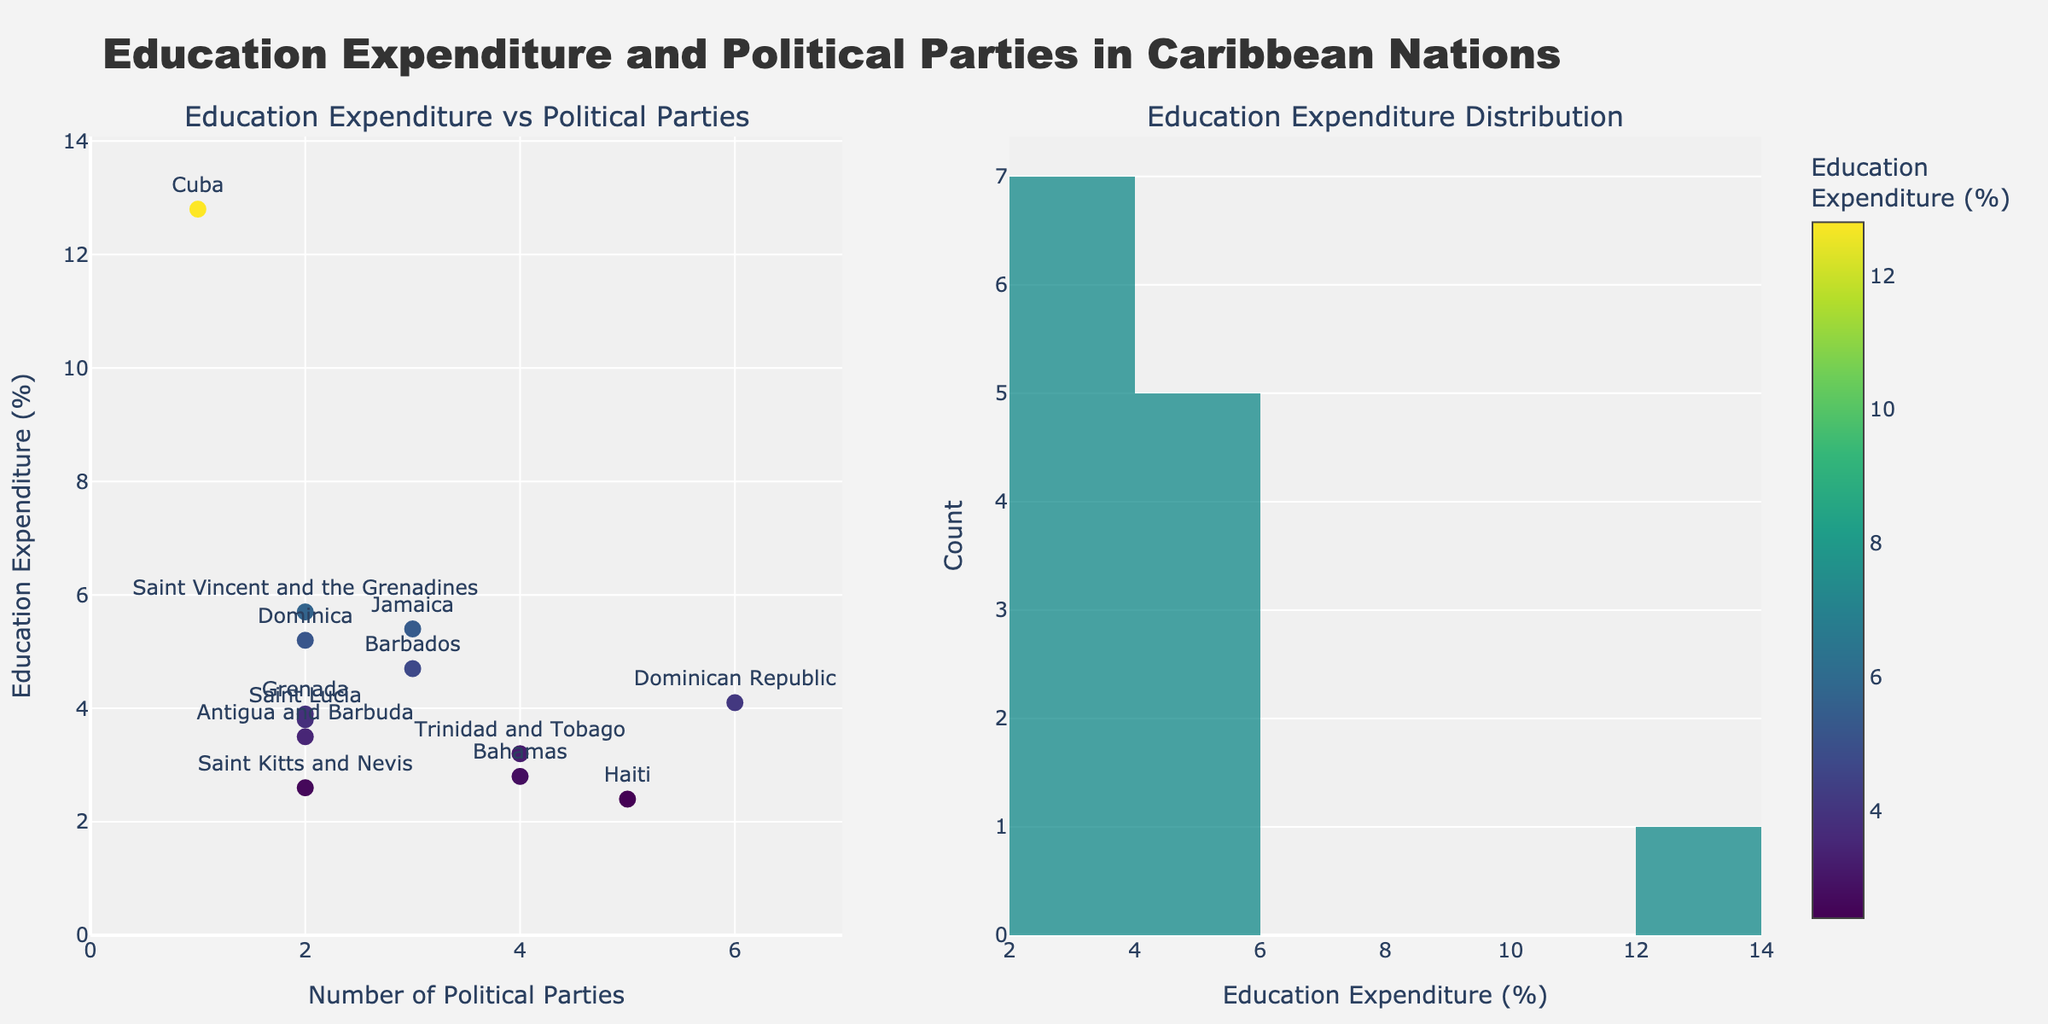What's the title of the subplot figure? The title is generally displayed at the top of the subplot figure. To find the title, you should read the largest text prominently positioned centrally.
Answer: "Education Expenditure and Political Parties in Caribbean Nations" How many Caribbean nations are represented in the scatter plot? To find the number of nations, count the different data points in the scatter plot; each point represents a different country.
Answer: 13 Which country has the highest education expenditure percentage? Look for the highest point in the scatter plot on the y-axis (Education Expenditure Percentage) and identify the country labeled closest to that point.
Answer: Cuba What is the range of the number of political parties in the Caribbean nations? Examine the x-axis of the scatter plot to determine the smallest and largest number of political parties.
Answer: 1 to 6 Which country has the most political parties and what is its education expenditure percentage? Locate the data point farthest to the right on the x-axis (Number of Political Parties) and note the country's label and corresponding y-axis value.
Answer: Dominican Republic, 4.1% What is the average education expenditure percentage for countries with 2 political parties? Collect the education expenditure percentages for countries with 2 political parties, sum them, and divide by the number of these countries to find the average.
Answer: (3.5 + 5.2 + 3.9 + 2.6 + 3.8 + 5.7) / 6 = 4.12% How does Haiti's education expenditure compare to Jamaica's? Identify Haiti and Jamaica on the scatter plot. Compare their positions on the y-axis for education expenditure percentages.
Answer: Haiti's (2.4%) is lower than Jamaica's (5.4%) Which education expenditure value appears most frequently among the Caribbean nations? Observe the histogram for education expenditure distribution and locate the bin with the highest count.
Answer: 3.5% to 4% Is there a visible trend between the number of political parties and education expenditure? Examine the pattern formed by the scatter plot's data points to determine if there's a discernible upward or downward trend.
Answer: There's no clear trend What is the education expenditure percentage of the country with 4 political parties having the lowest value? Identify the countries with 4 political parties on the scatter plot; find the one with the lowest position on the y-axis and note its education expenditure.
Answer: Bahamas, 2.8% 